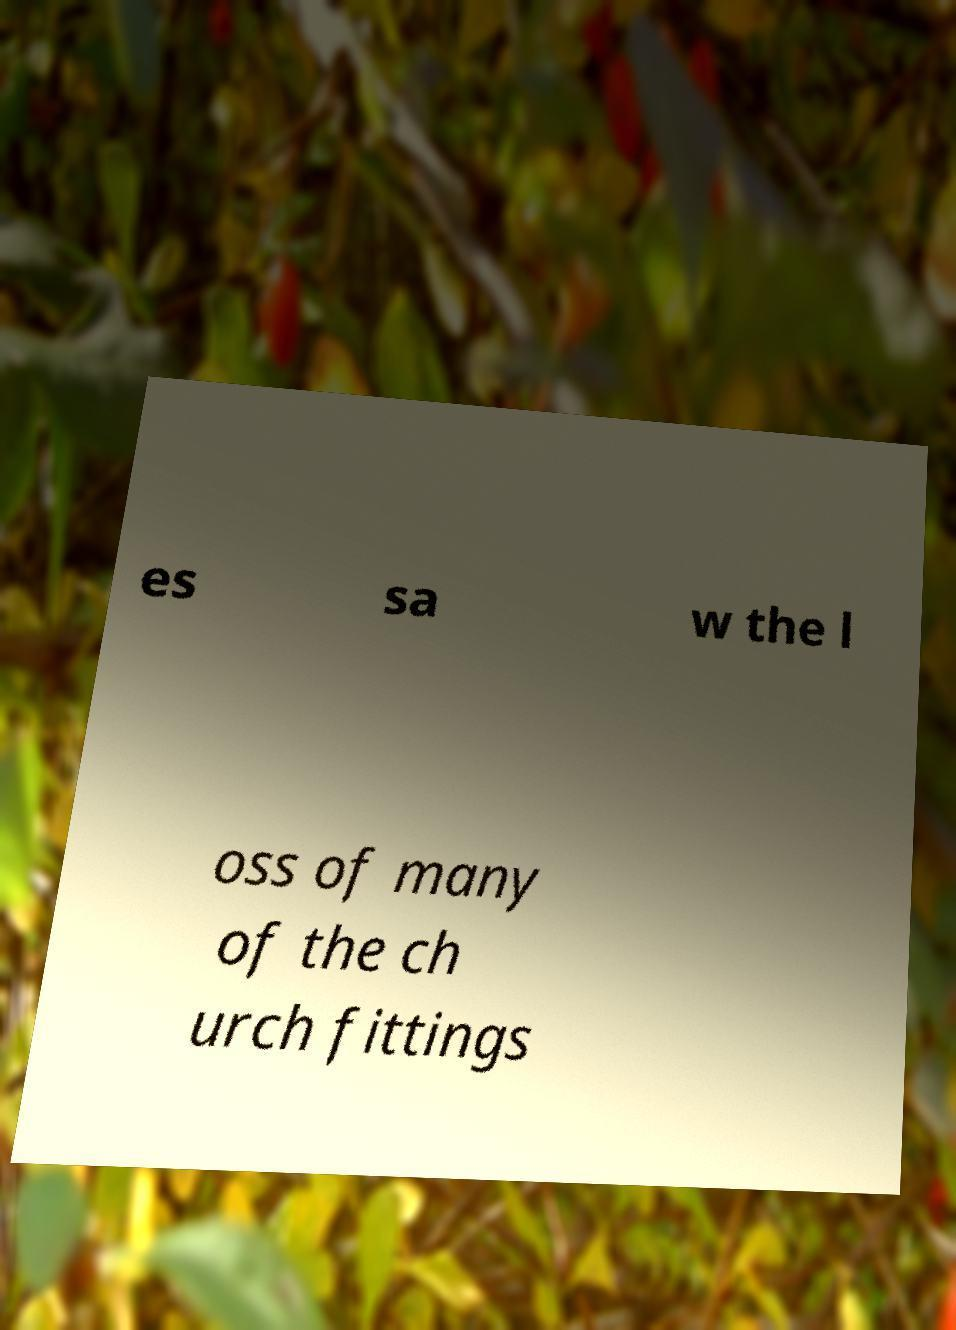Could you assist in decoding the text presented in this image and type it out clearly? es sa w the l oss of many of the ch urch fittings 